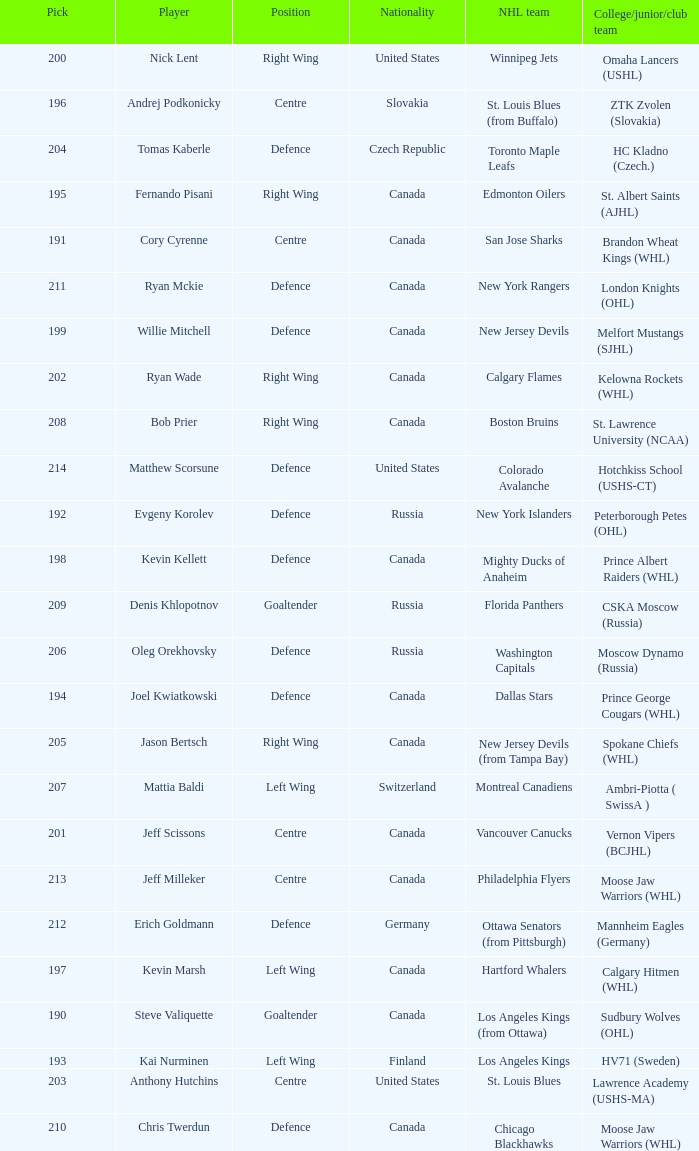Name the college for andrej podkonicky ZTK Zvolen (Slovakia). 